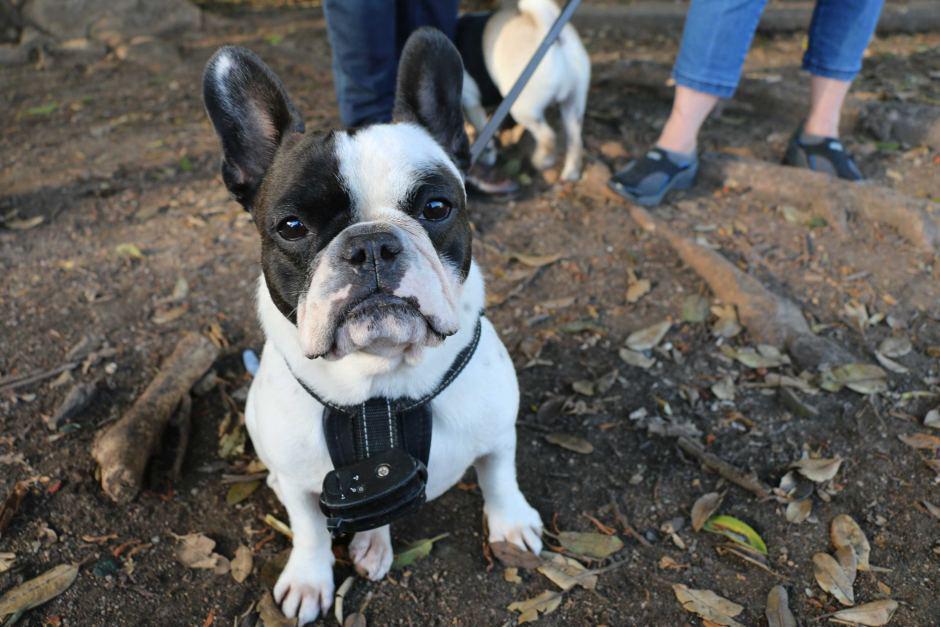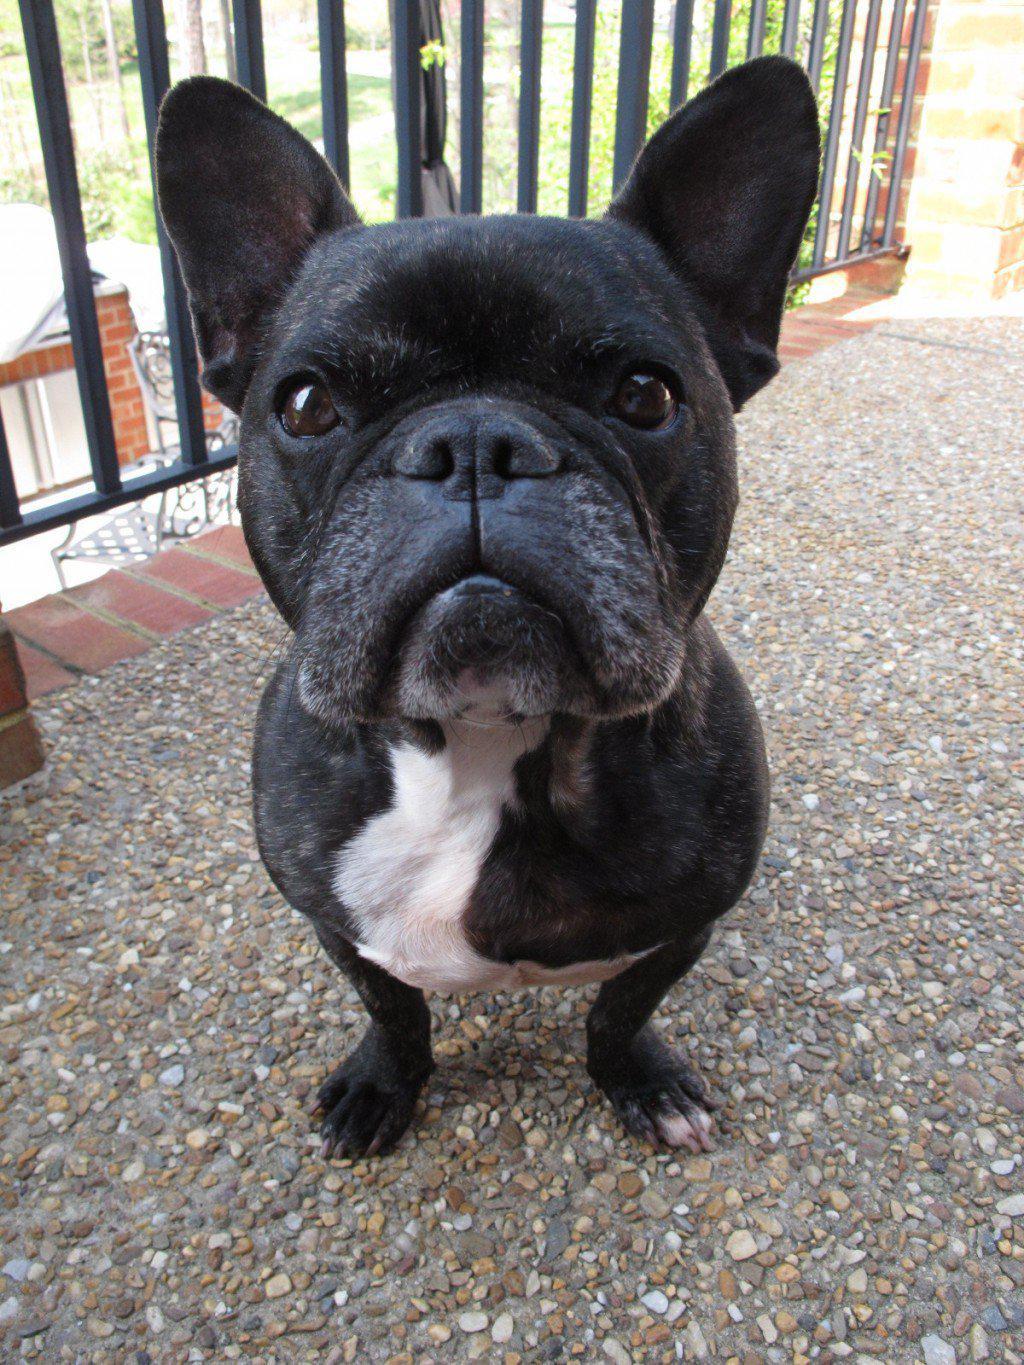The first image is the image on the left, the second image is the image on the right. Assess this claim about the two images: "The french bulldog in the left image wears a collar and has a black container in front of its chest.". Correct or not? Answer yes or no. Yes. The first image is the image on the left, the second image is the image on the right. Assess this claim about the two images: "There are at least 3 dogs.". Correct or not? Answer yes or no. Yes. 